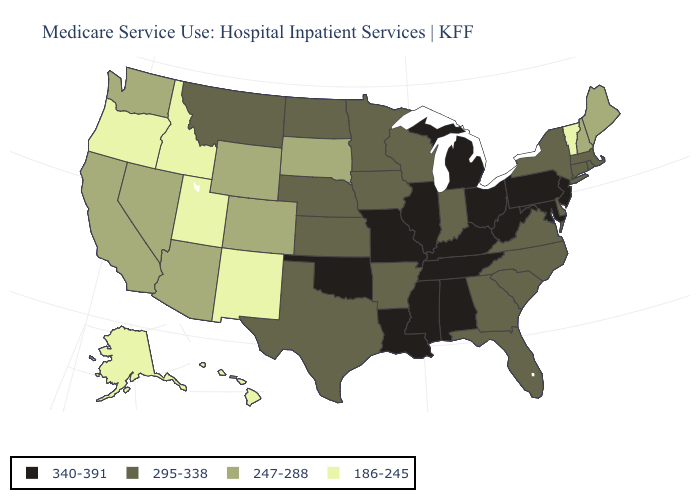Does Montana have the highest value in the West?
Keep it brief. Yes. What is the lowest value in states that border Utah?
Quick response, please. 186-245. What is the value of Hawaii?
Be succinct. 186-245. What is the lowest value in states that border Texas?
Give a very brief answer. 186-245. Which states hav the highest value in the Northeast?
Answer briefly. New Jersey, Pennsylvania. What is the value of Massachusetts?
Concise answer only. 295-338. Name the states that have a value in the range 295-338?
Quick response, please. Arkansas, Connecticut, Delaware, Florida, Georgia, Indiana, Iowa, Kansas, Massachusetts, Minnesota, Montana, Nebraska, New York, North Carolina, North Dakota, Rhode Island, South Carolina, Texas, Virginia, Wisconsin. What is the value of Iowa?
Keep it brief. 295-338. What is the value of Hawaii?
Short answer required. 186-245. What is the lowest value in the West?
Quick response, please. 186-245. Does Michigan have the highest value in the MidWest?
Write a very short answer. Yes. Does the first symbol in the legend represent the smallest category?
Answer briefly. No. Among the states that border New Hampshire , does Vermont have the highest value?
Short answer required. No. Name the states that have a value in the range 247-288?
Write a very short answer. Arizona, California, Colorado, Maine, Nevada, New Hampshire, South Dakota, Washington, Wyoming. 